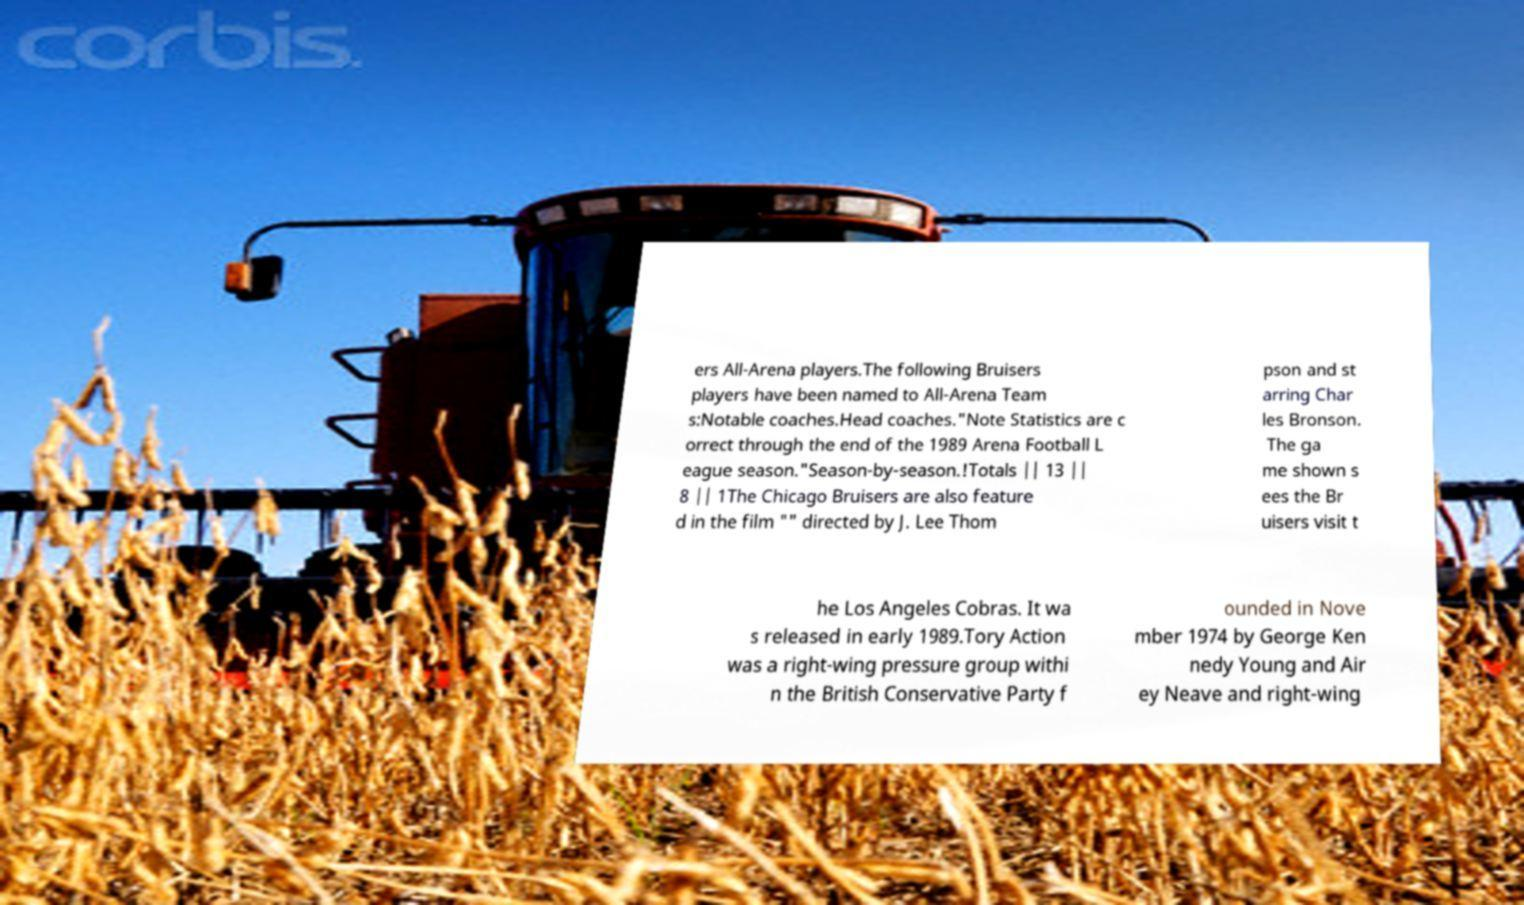Can you read and provide the text displayed in the image?This photo seems to have some interesting text. Can you extract and type it out for me? ers All-Arena players.The following Bruisers players have been named to All-Arena Team s:Notable coaches.Head coaches."Note Statistics are c orrect through the end of the 1989 Arena Football L eague season."Season-by-season.!Totals || 13 || 8 || 1The Chicago Bruisers are also feature d in the film "" directed by J. Lee Thom pson and st arring Char les Bronson. The ga me shown s ees the Br uisers visit t he Los Angeles Cobras. It wa s released in early 1989.Tory Action was a right-wing pressure group withi n the British Conservative Party f ounded in Nove mber 1974 by George Ken nedy Young and Air ey Neave and right-wing 